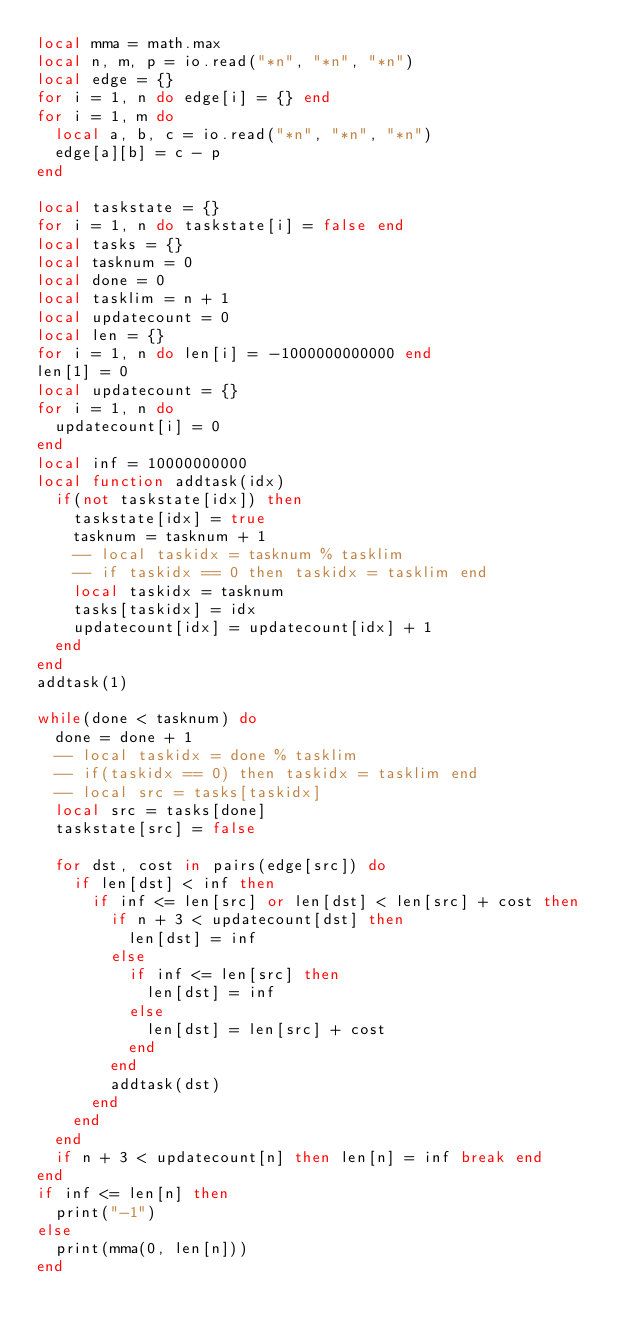Convert code to text. <code><loc_0><loc_0><loc_500><loc_500><_Lua_>local mma = math.max
local n, m, p = io.read("*n", "*n", "*n")
local edge = {}
for i = 1, n do edge[i] = {} end
for i = 1, m do
  local a, b, c = io.read("*n", "*n", "*n")
  edge[a][b] = c - p
end

local taskstate = {}
for i = 1, n do taskstate[i] = false end
local tasks = {}
local tasknum = 0
local done = 0
local tasklim = n + 1
local updatecount = 0
local len = {}
for i = 1, n do len[i] = -1000000000000 end
len[1] = 0
local updatecount = {}
for i = 1, n do
  updatecount[i] = 0
end
local inf = 10000000000
local function addtask(idx)
  if(not taskstate[idx]) then
    taskstate[idx] = true
    tasknum = tasknum + 1
    -- local taskidx = tasknum % tasklim
    -- if taskidx == 0 then taskidx = tasklim end
    local taskidx = tasknum
    tasks[taskidx] = idx
    updatecount[idx] = updatecount[idx] + 1
  end
end
addtask(1)

while(done < tasknum) do
  done = done + 1
  -- local taskidx = done % tasklim
  -- if(taskidx == 0) then taskidx = tasklim end
  -- local src = tasks[taskidx]
  local src = tasks[done]
  taskstate[src] = false

  for dst, cost in pairs(edge[src]) do
    if len[dst] < inf then
      if inf <= len[src] or len[dst] < len[src] + cost then
        if n + 3 < updatecount[dst] then
          len[dst] = inf
        else
          if inf <= len[src] then
            len[dst] = inf
          else
            len[dst] = len[src] + cost
          end
        end
        addtask(dst)
      end
    end
  end
  if n + 3 < updatecount[n] then len[n] = inf break end
end
if inf <= len[n] then
  print("-1")
else
  print(mma(0, len[n]))
end
</code> 